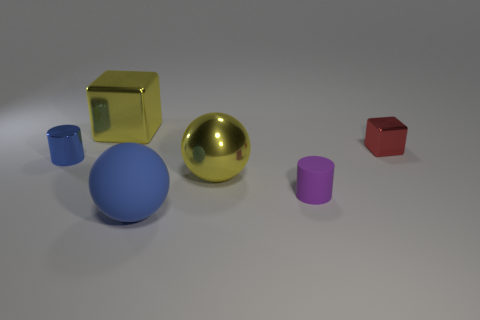There is a tiny object that is the same color as the big matte sphere; what material is it?
Provide a short and direct response. Metal. What number of other things are there of the same color as the rubber sphere?
Offer a very short reply. 1. Do the object that is behind the small red metal object and the tiny metallic thing that is to the left of the purple matte object have the same shape?
Your response must be concise. No. How many things are either small cylinders that are on the right side of the yellow shiny cube or metal objects that are left of the matte ball?
Your answer should be compact. 3. How many other objects are the same material as the big yellow cube?
Your response must be concise. 3. Are the tiny thing on the left side of the big metal block and the small red object made of the same material?
Offer a terse response. Yes. Are there more tiny matte cylinders left of the blue metallic thing than tiny cubes in front of the red thing?
Provide a succinct answer. No. How many things are cubes to the right of the purple object or small metal cylinders?
Offer a very short reply. 2. What is the shape of the big yellow thing that is made of the same material as the big yellow ball?
Provide a succinct answer. Cube. Is there any other thing that has the same shape as the tiny purple object?
Ensure brevity in your answer.  Yes. 